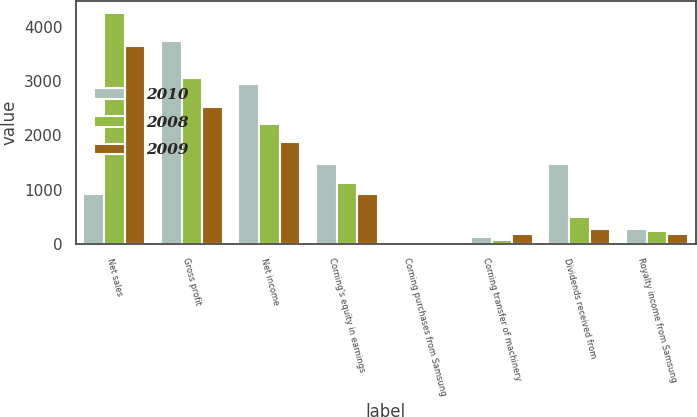Convert chart to OTSL. <chart><loc_0><loc_0><loc_500><loc_500><stacked_bar_chart><ecel><fcel>Net sales<fcel>Gross profit<fcel>Net income<fcel>Corning's equity in earnings<fcel>Corning purchases from Samsung<fcel>Corning transfer of machinery<fcel>Dividends received from<fcel>Royalty income from Samsung<nl><fcel>2010<fcel>927<fcel>3731<fcel>2946<fcel>1473<fcel>33<fcel>121<fcel>1474<fcel>265<nl><fcel>2008<fcel>4250<fcel>3053<fcel>2212<fcel>1115<fcel>37<fcel>78<fcel>490<fcel>231<nl><fcel>2009<fcel>3636<fcel>2521<fcel>1874<fcel>927<fcel>30<fcel>173<fcel>278<fcel>184<nl></chart> 